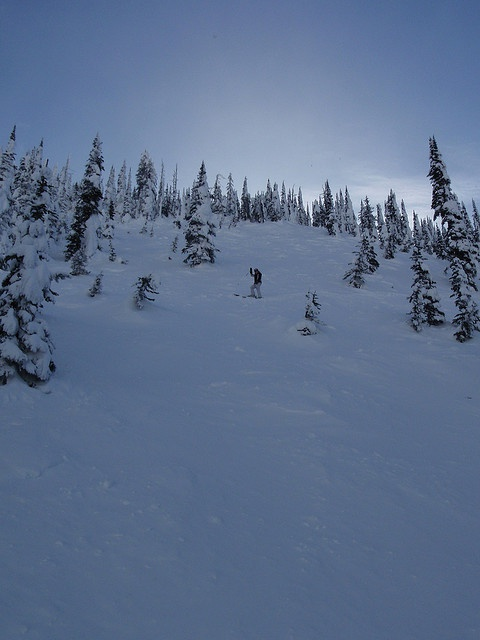Describe the objects in this image and their specific colors. I can see people in blue, gray, and black tones and skis in blue, gray, black, and navy tones in this image. 